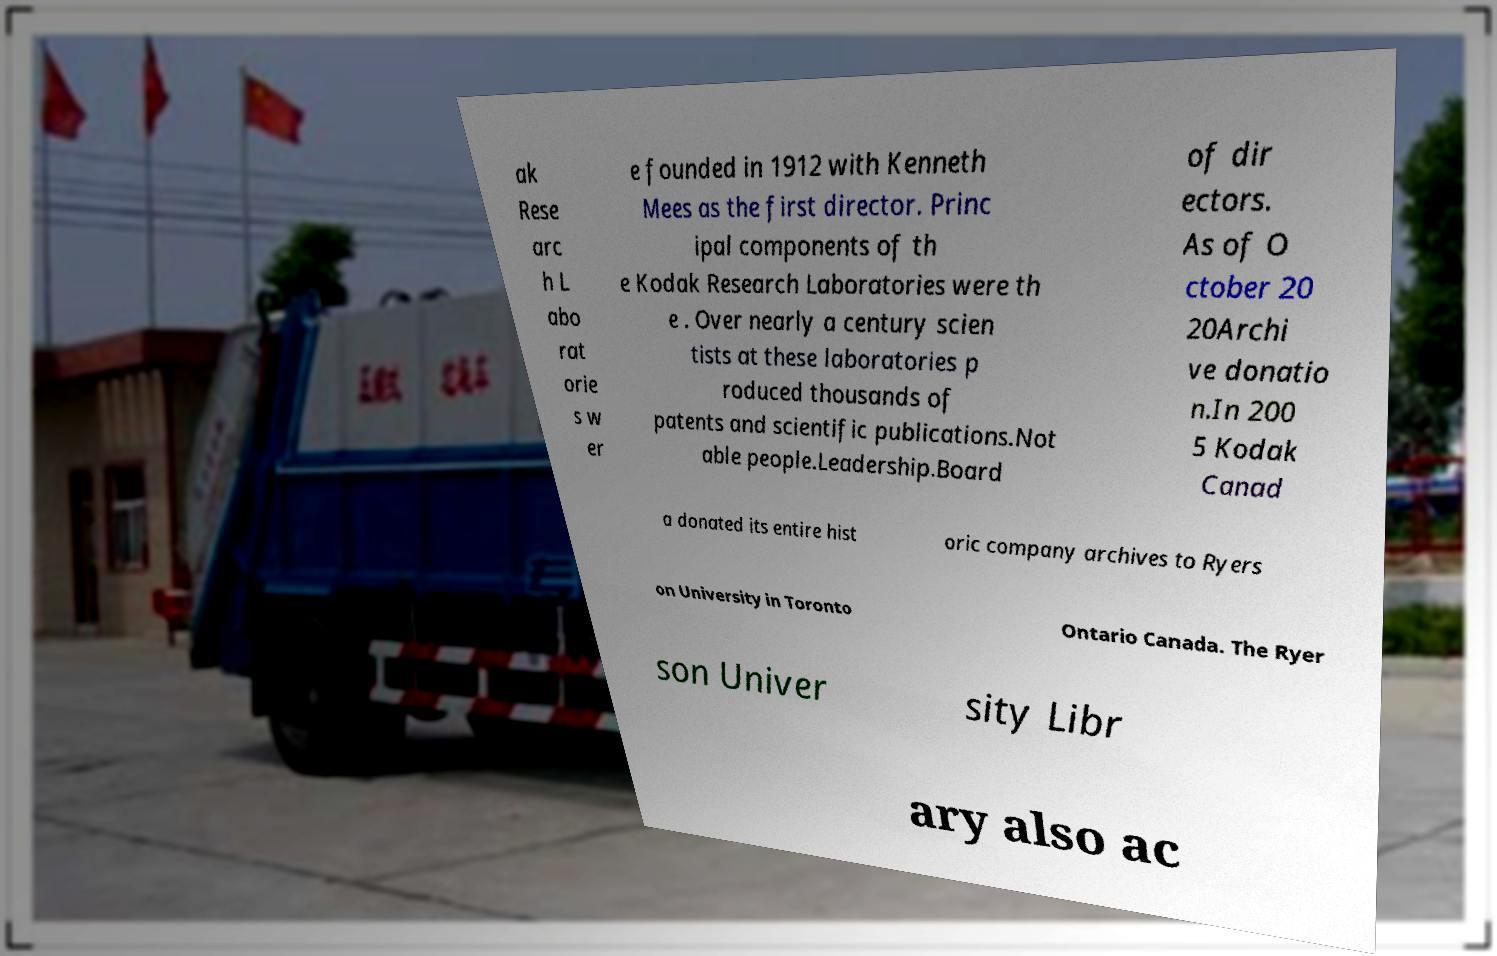I need the written content from this picture converted into text. Can you do that? ak Rese arc h L abo rat orie s w er e founded in 1912 with Kenneth Mees as the first director. Princ ipal components of th e Kodak Research Laboratories were th e . Over nearly a century scien tists at these laboratories p roduced thousands of patents and scientific publications.Not able people.Leadership.Board of dir ectors. As of O ctober 20 20Archi ve donatio n.In 200 5 Kodak Canad a donated its entire hist oric company archives to Ryers on University in Toronto Ontario Canada. The Ryer son Univer sity Libr ary also ac 